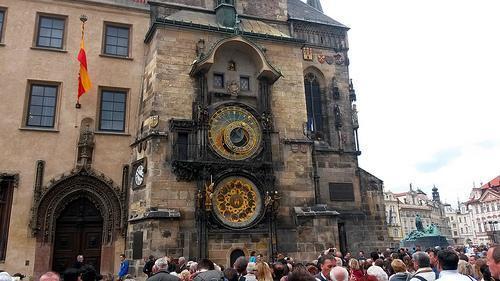How many flags are shown?
Give a very brief answer. 1. 